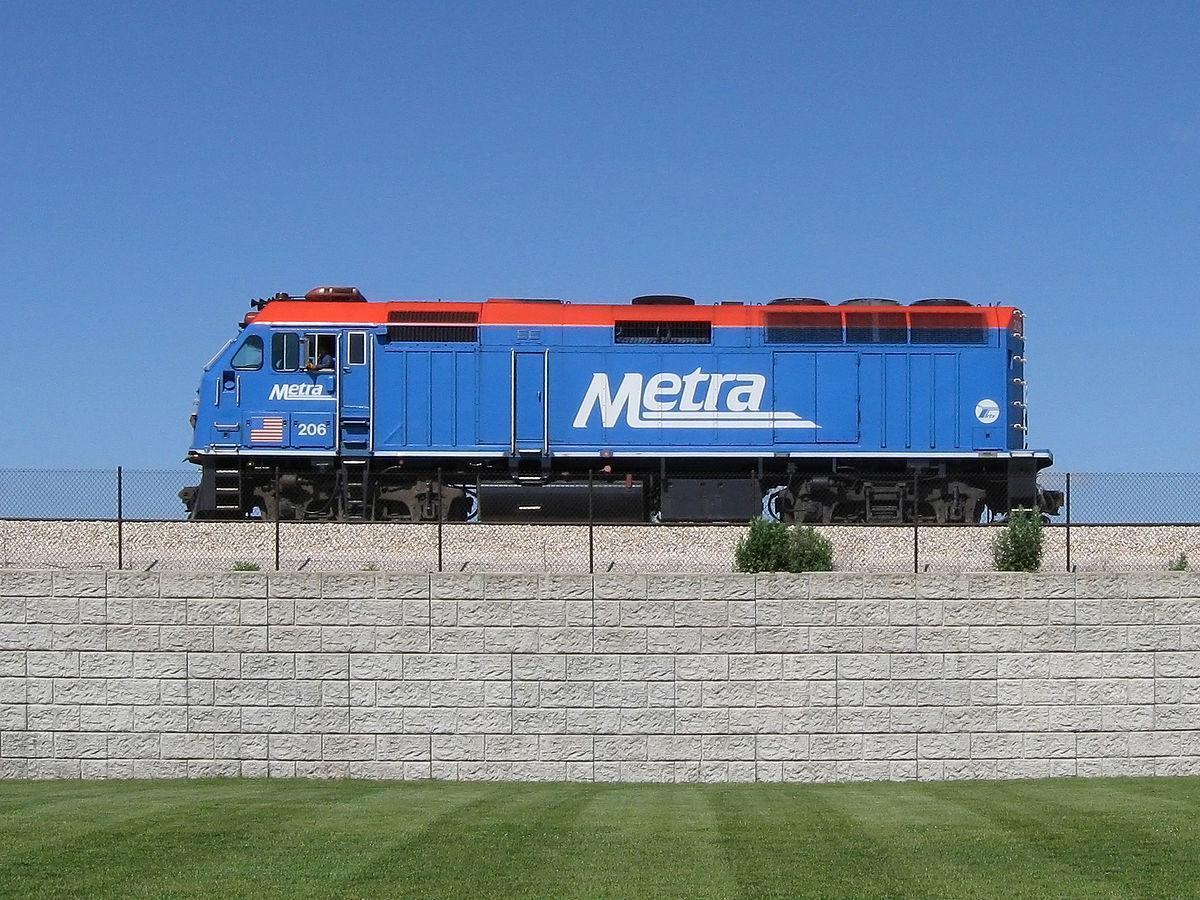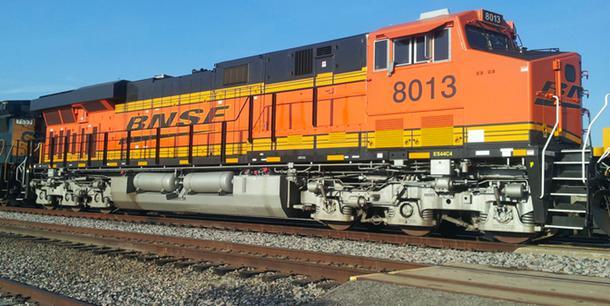The first image is the image on the left, the second image is the image on the right. Analyze the images presented: Is the assertion "Thers is at least one ornage train." valid? Answer yes or no. Yes. 